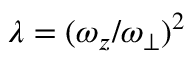Convert formula to latex. <formula><loc_0><loc_0><loc_500><loc_500>\lambda = ( \omega _ { z } / \omega _ { \perp } ) ^ { 2 }</formula> 